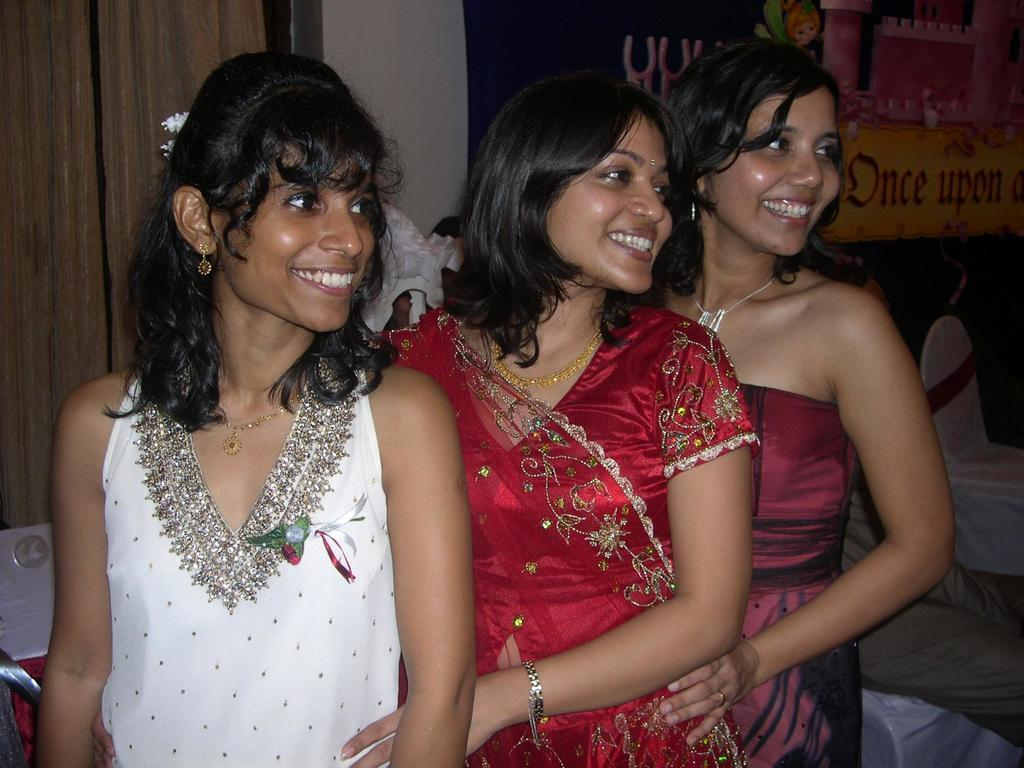What are the ladies in the image doing? The ladies in the image are standing and smiling. What objects can be seen in the image besides the ladies? There are chairs, a board, and a wall visible in the image. What type of steel is used to construct the chairs in the image? There is no information about the chairs being made of steel, nor is there any mention of steel in the image. 